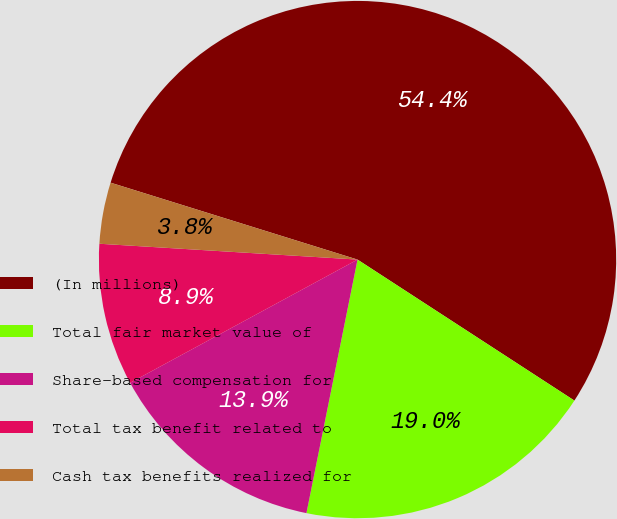<chart> <loc_0><loc_0><loc_500><loc_500><pie_chart><fcel>(In millions)<fcel>Total fair market value of<fcel>Share-based compensation for<fcel>Total tax benefit related to<fcel>Cash tax benefits realized for<nl><fcel>54.37%<fcel>18.99%<fcel>13.93%<fcel>8.88%<fcel>3.83%<nl></chart> 